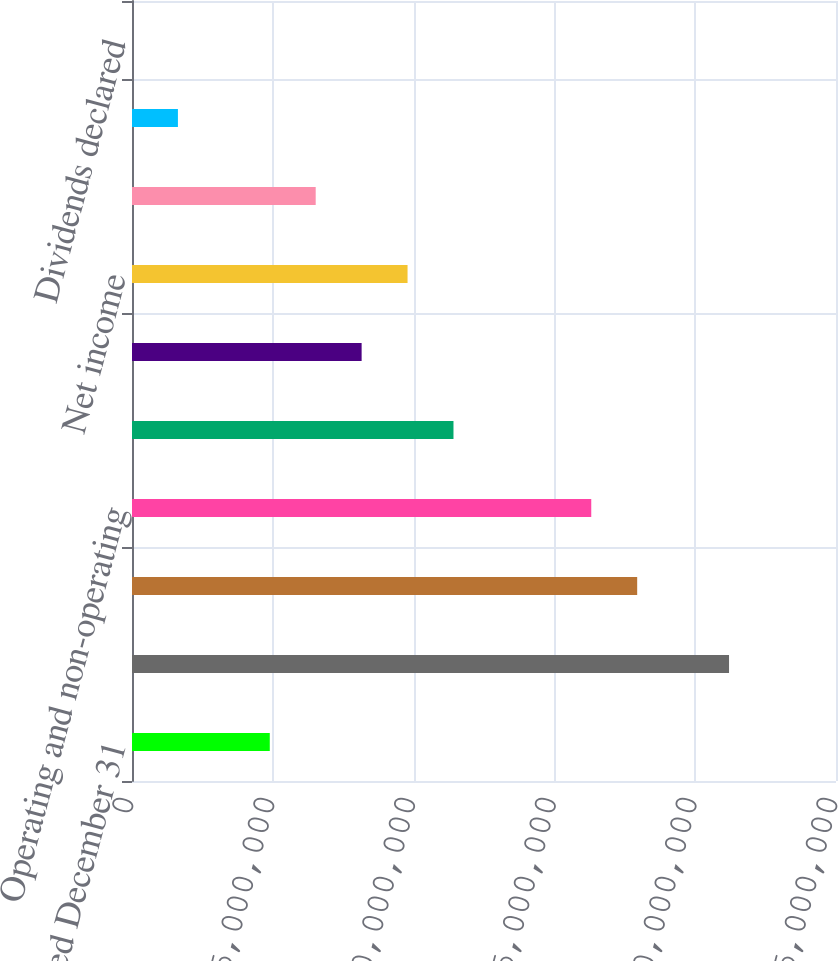<chart> <loc_0><loc_0><loc_500><loc_500><bar_chart><fcel>Year Ended December 31<fcel>Net sales<fcel>Cost of goods sold<fcel>Operating and non-operating<fcel>Income before taxes<fcel>Income taxes<fcel>Net income<fcel>Weighted average common shares<fcel>Diluted net income<fcel>Dividends declared<nl><fcel>4.89264e+06<fcel>2.12014e+07<fcel>1.79397e+07<fcel>1.63088e+07<fcel>1.14162e+07<fcel>8.1544e+06<fcel>9.78528e+06<fcel>6.52352e+06<fcel>1.63088e+06<fcel>2.7<nl></chart> 